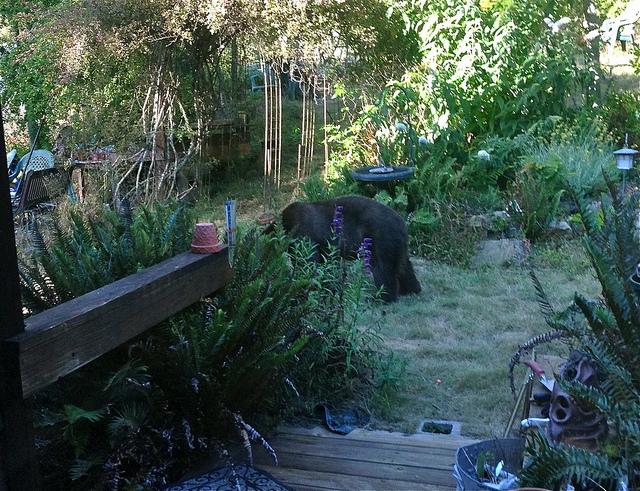Do these animals travel in herds?
Quick response, please. No. Would it be safe to have a bear in your backyard?
Be succinct. No. What animal is in the background?
Write a very short answer. Bear. Is there more than one animal in the picture?
Write a very short answer. No. 